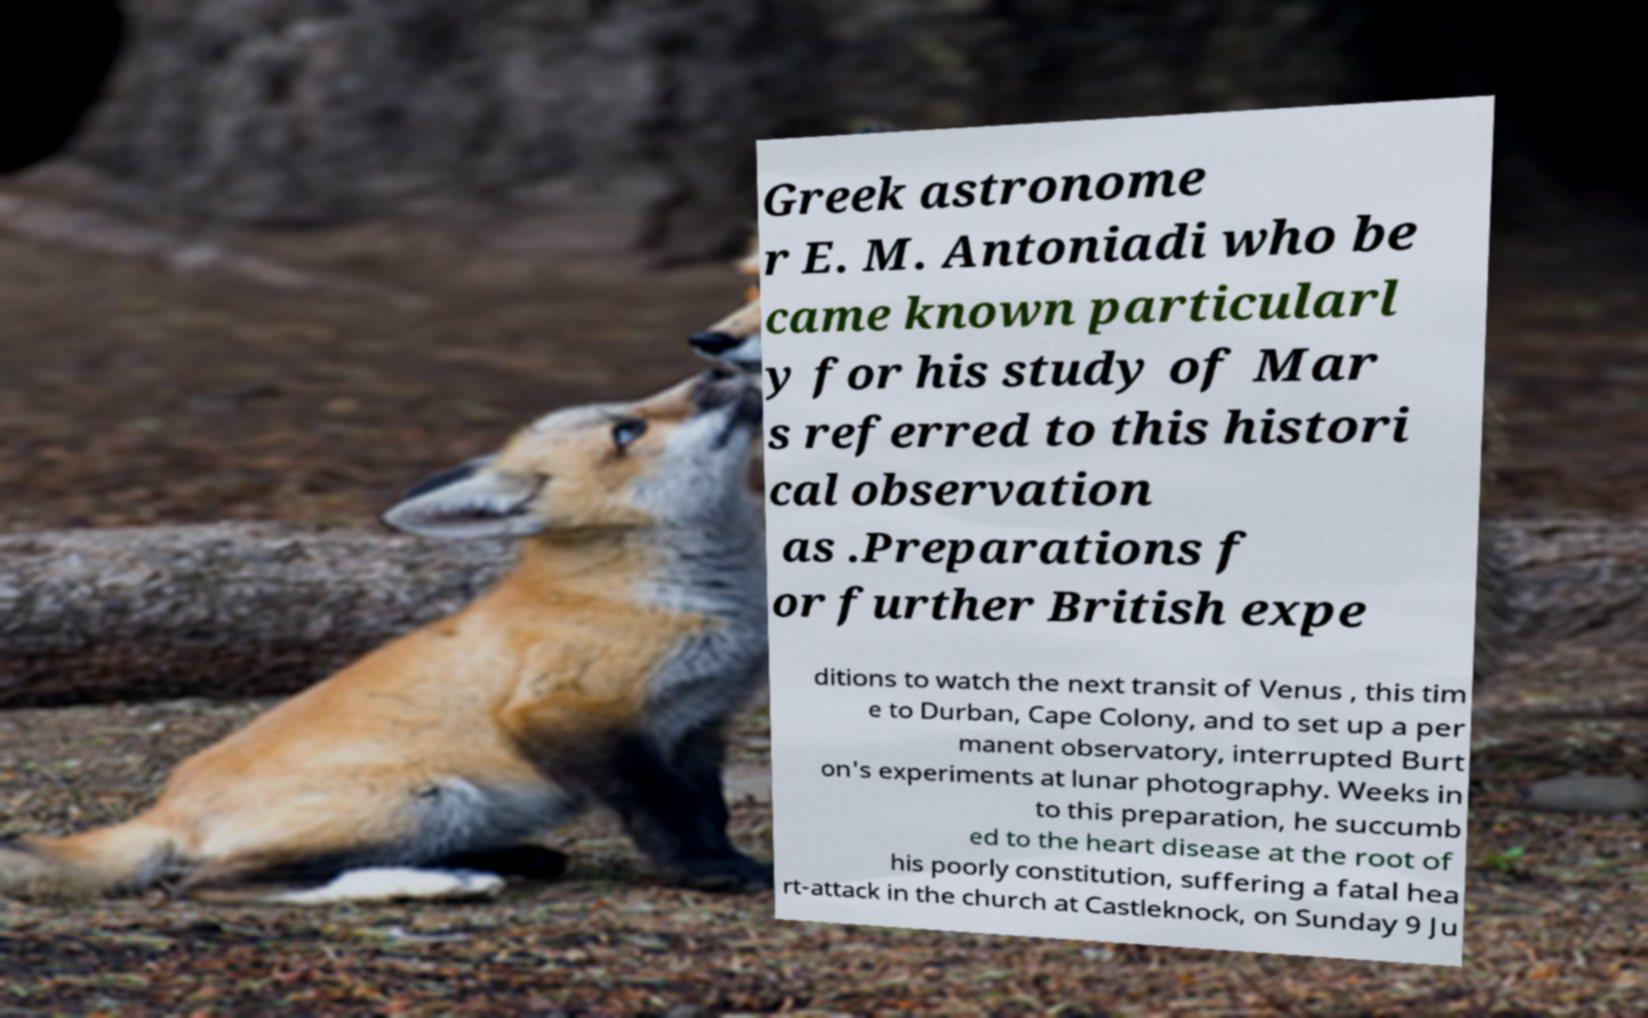Could you assist in decoding the text presented in this image and type it out clearly? Greek astronome r E. M. Antoniadi who be came known particularl y for his study of Mar s referred to this histori cal observation as .Preparations f or further British expe ditions to watch the next transit of Venus , this tim e to Durban, Cape Colony, and to set up a per manent observatory, interrupted Burt on's experiments at lunar photography. Weeks in to this preparation, he succumb ed to the heart disease at the root of his poorly constitution, suffering a fatal hea rt-attack in the church at Castleknock, on Sunday 9 Ju 